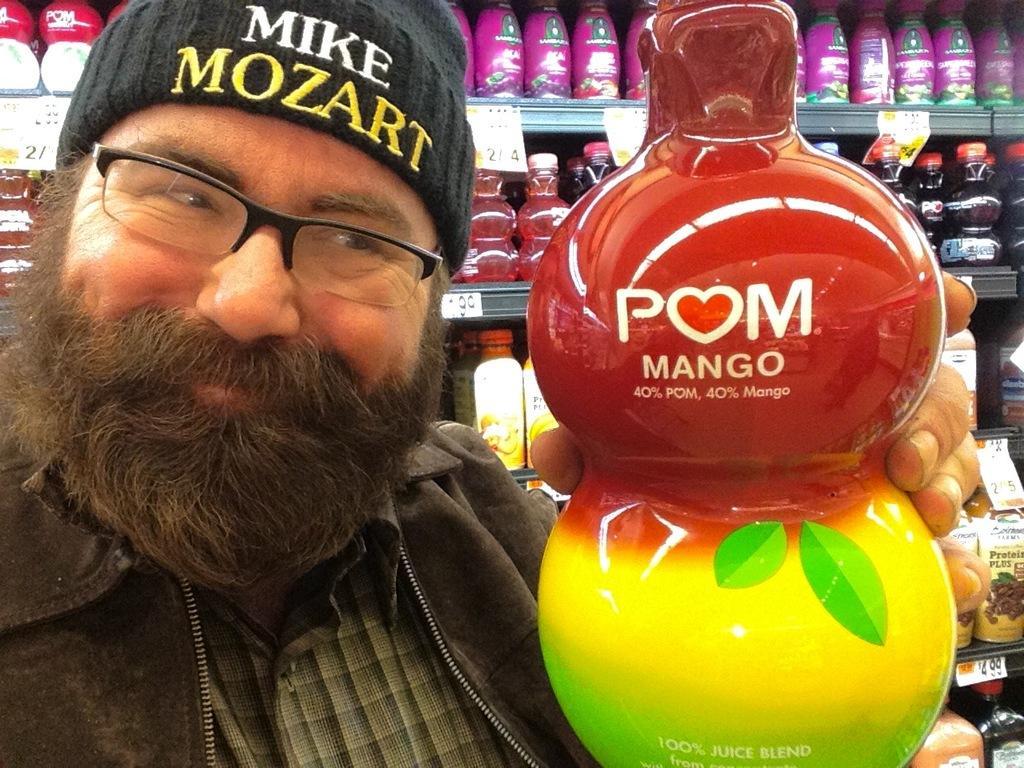Can you describe this image briefly? There is one person standing and holding an object as we can see in the middle of this image. We can see bottles kept in the racks in the background. 